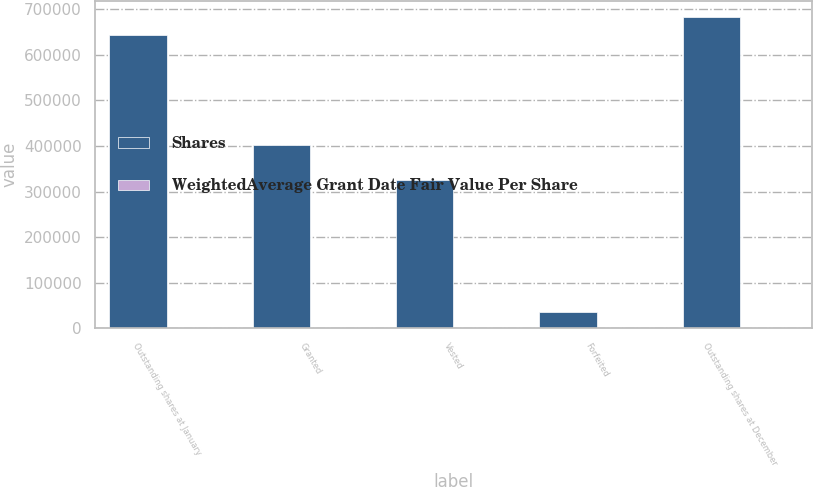Convert chart to OTSL. <chart><loc_0><loc_0><loc_500><loc_500><stacked_bar_chart><ecel><fcel>Outstanding shares at January<fcel>Granted<fcel>Vested<fcel>Forfeited<fcel>Outstanding shares at December<nl><fcel>Shares<fcel>642729<fcel>401358<fcel>324862<fcel>35751<fcel>683474<nl><fcel>WeightedAverage Grant Date Fair Value Per Share<fcel>75.88<fcel>70.89<fcel>71.83<fcel>77.38<fcel>74.8<nl></chart> 